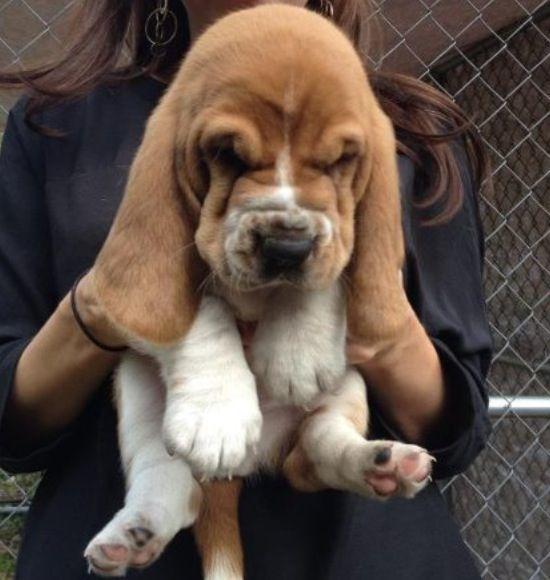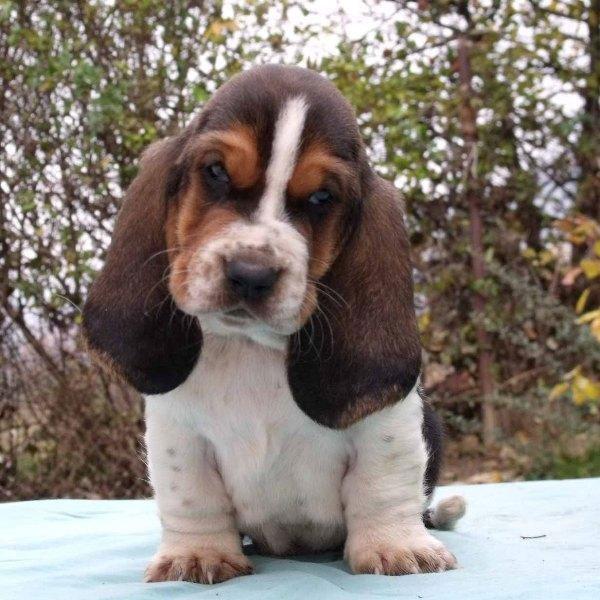The first image is the image on the left, the second image is the image on the right. Examine the images to the left and right. Is the description "One of the dogs is right next to a human, and being touched by the human." accurate? Answer yes or no. Yes. The first image is the image on the left, the second image is the image on the right. Considering the images on both sides, is "One image shows a basset hound being touched by a human hand." valid? Answer yes or no. Yes. 